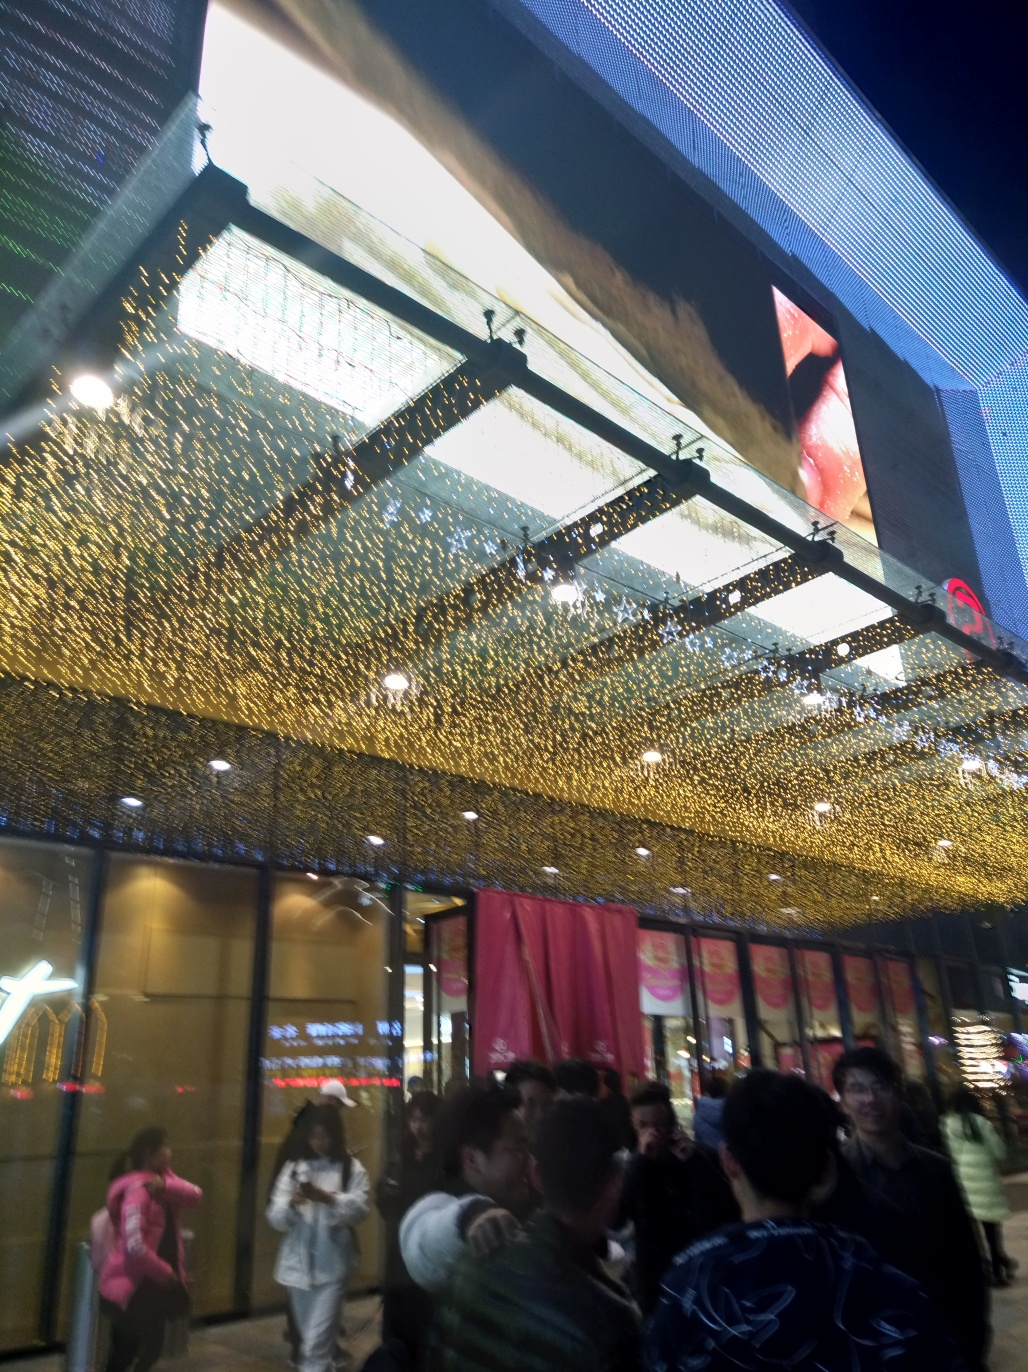What kind of social activity is happening in this image? In the image, we see a group of people gathered closely together. They could be waiting in line or congregating around an event or attraction that's outside the frame. Interaction between the individuals suggests a social or communal engagement—a common sight in areas where people meet for leisure or entertainment. Does this image suggest any particular time of year? While there are no definitive markers for a specific time of year, the image does have a festive ambiance due to the golden lights, which might hint that it was taken during a holiday season or a special event. Additionally, the attire of the people suggests it's not overly cold, pointing possibly to a time outside of the winter months. 